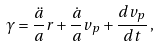<formula> <loc_0><loc_0><loc_500><loc_500>\gamma = \frac { \ddot { a } } { a } r + \frac { \dot { a } } { a } v _ { p } + \frac { d v _ { p } } { d t } \, ,</formula> 